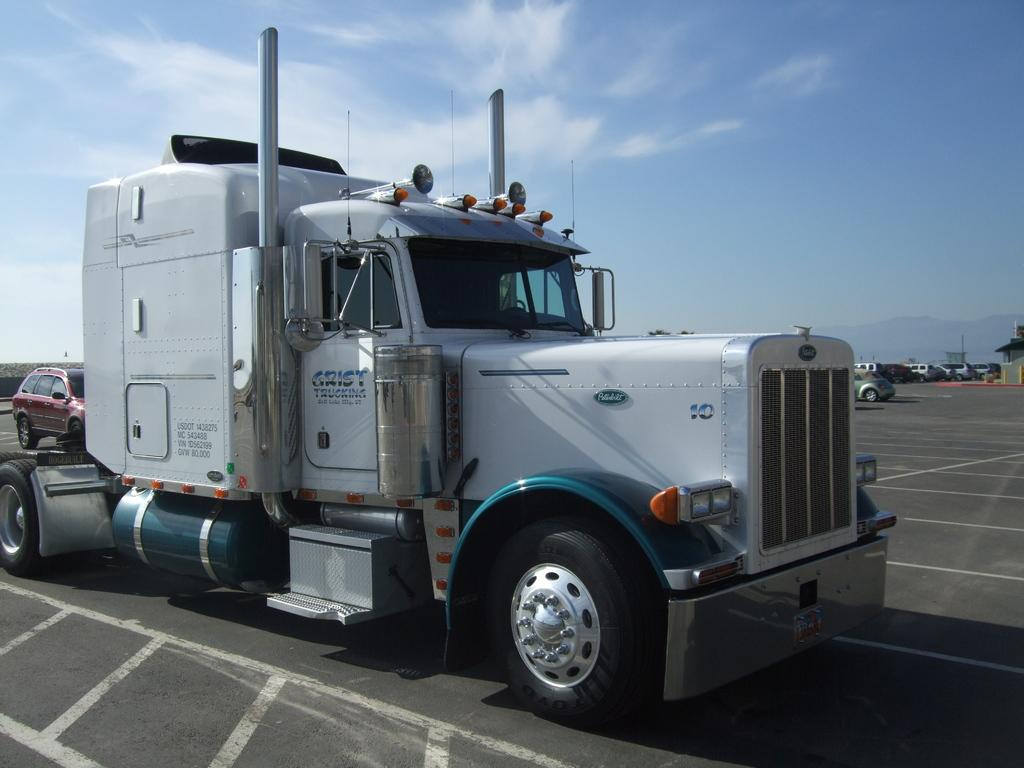What is the main subject in the center of the image? There is a vehicle in the center of the image. What else can be seen in the background of the image? There are cars and a hill visible in the background of the image. What is the surface on which the vehicle is located? There is a road at the bottom of the image. What is visible above the hill and cars in the background? The sky is visible in the background of the image. How does the egg self-current in the image? There is no egg or self-currenting device present in the image. 